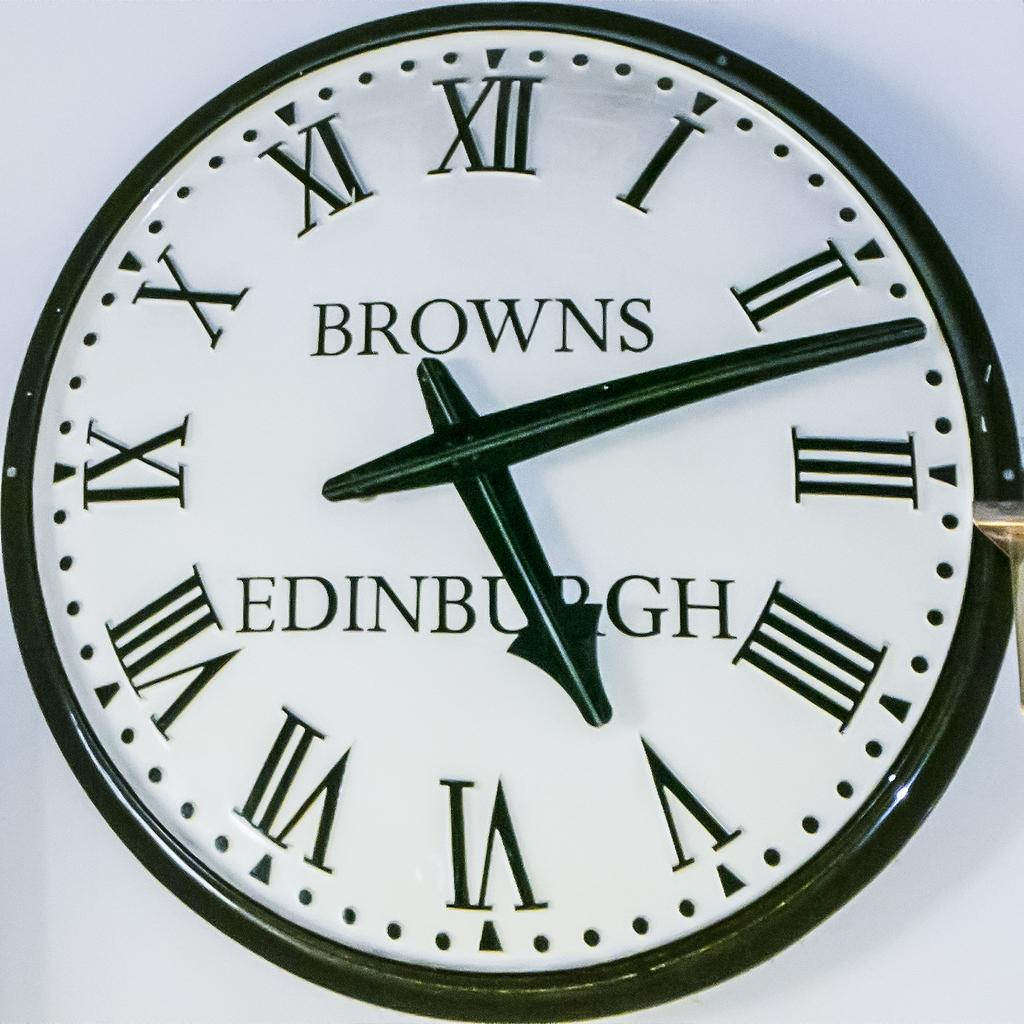<image>
Present a compact description of the photo's key features. Face of a watch which says EDINBURGH on it. 